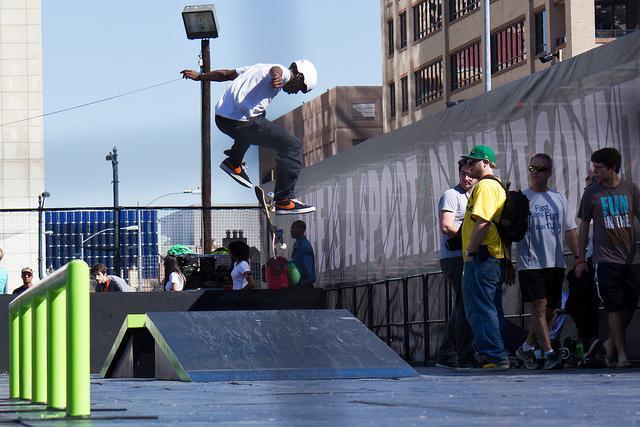How many people are in the picture?
Give a very brief answer. 6. How many of the birds are sitting?
Give a very brief answer. 0. 